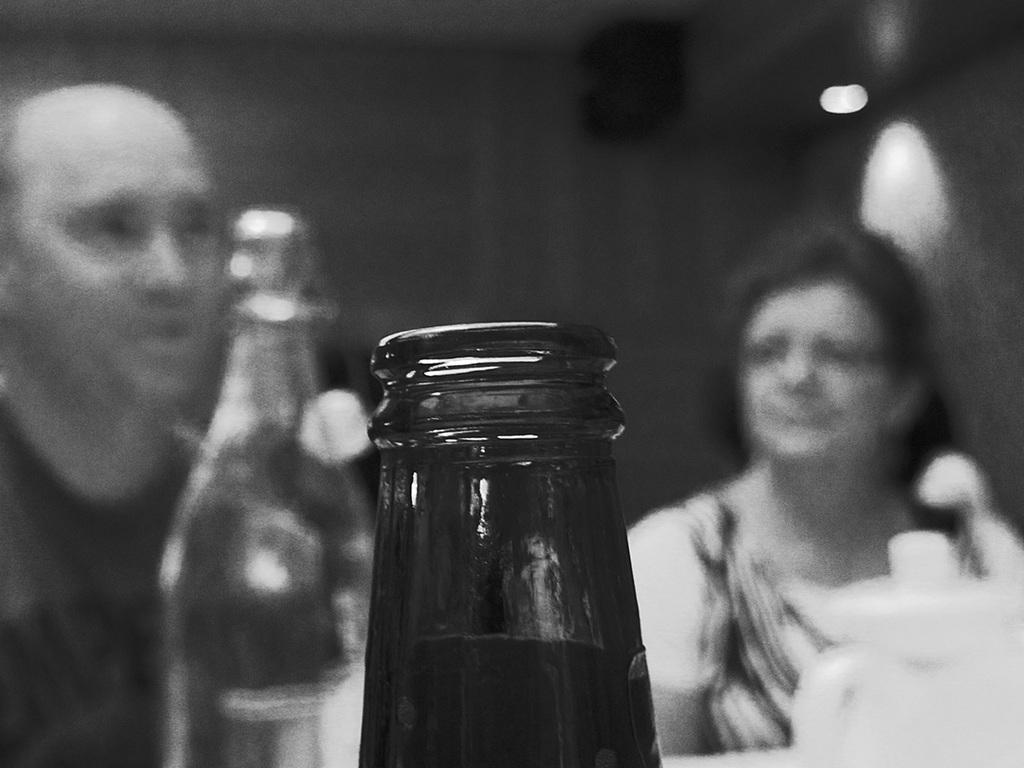What is the color scheme of the image? The image is black and white. How many people are present in the image? There is a woman and a man in the image. Can you describe the quality of the image? The image is blurry. What object is highlighted in the image? A bottle is highlighted in the image. What can be seen providing illumination in the image? There is a light in the image. How does the woman express her disgust in the image? There is no indication of disgust in the image, as it is black and white and blurry. What type of tray is being used by the man in the image? There is no tray present in the image. 